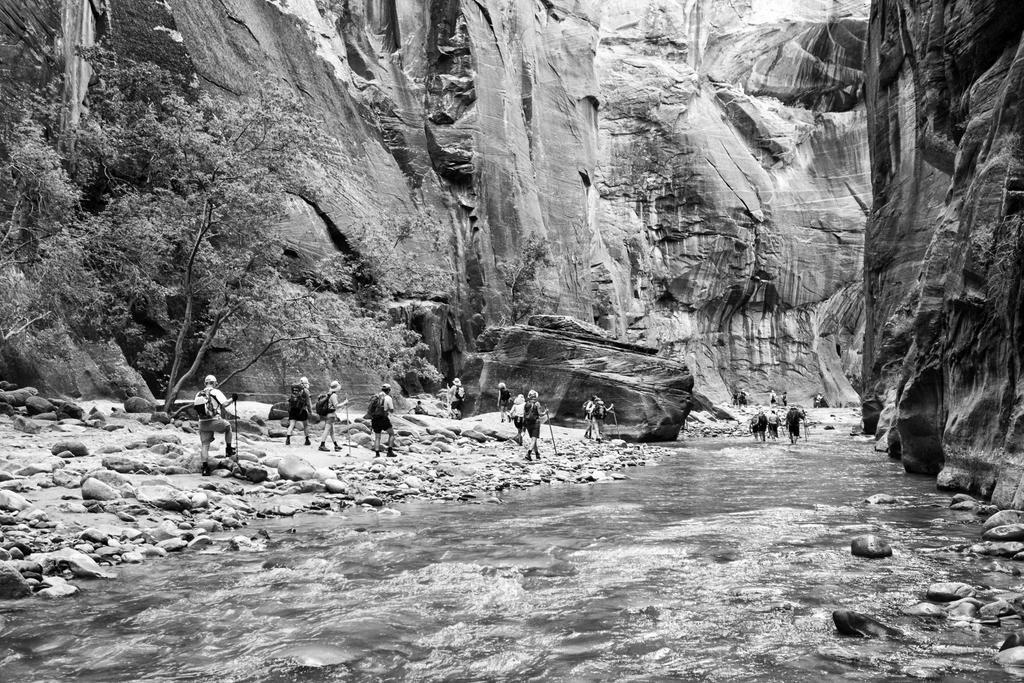What is the color scheme of the image? The image is black and white. What can be seen in the foreground of the image? There are groups of people in the image. What is visible in the background of the image? There are trees and hills behind the people. What objects are present on the right side of the image? There are stones and water on the right side of the image. What type of print can be seen on the celery in the image? There is no celery present in the image, and therefore no print can be observed. What kind of rock is visible on the left side of the image? The provided facts do not mention any rocks, and the image does not show any rocks on the left side. 